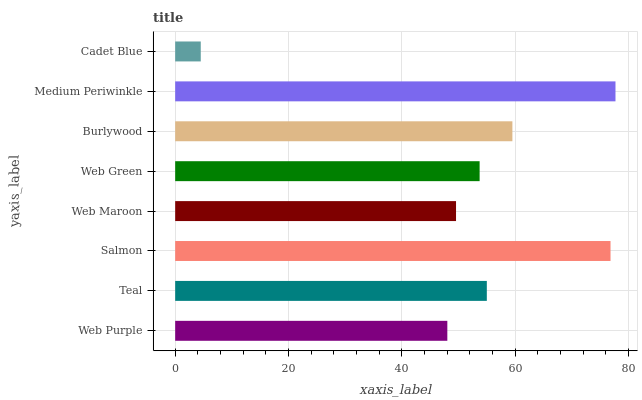Is Cadet Blue the minimum?
Answer yes or no. Yes. Is Medium Periwinkle the maximum?
Answer yes or no. Yes. Is Teal the minimum?
Answer yes or no. No. Is Teal the maximum?
Answer yes or no. No. Is Teal greater than Web Purple?
Answer yes or no. Yes. Is Web Purple less than Teal?
Answer yes or no. Yes. Is Web Purple greater than Teal?
Answer yes or no. No. Is Teal less than Web Purple?
Answer yes or no. No. Is Teal the high median?
Answer yes or no. Yes. Is Web Green the low median?
Answer yes or no. Yes. Is Cadet Blue the high median?
Answer yes or no. No. Is Web Purple the low median?
Answer yes or no. No. 